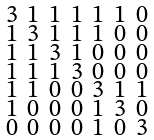Convert formula to latex. <formula><loc_0><loc_0><loc_500><loc_500>\begin{smallmatrix} 3 & 1 & 1 & 1 & 1 & 1 & 0 \\ 1 & 3 & 1 & 1 & 1 & 0 & 0 \\ 1 & 1 & 3 & 1 & 0 & 0 & 0 \\ 1 & 1 & 1 & 3 & 0 & 0 & 0 \\ 1 & 1 & 0 & 0 & 3 & 1 & 1 \\ 1 & 0 & 0 & 0 & 1 & 3 & 0 \\ 0 & 0 & 0 & 0 & 1 & 0 & 3 \end{smallmatrix}</formula> 